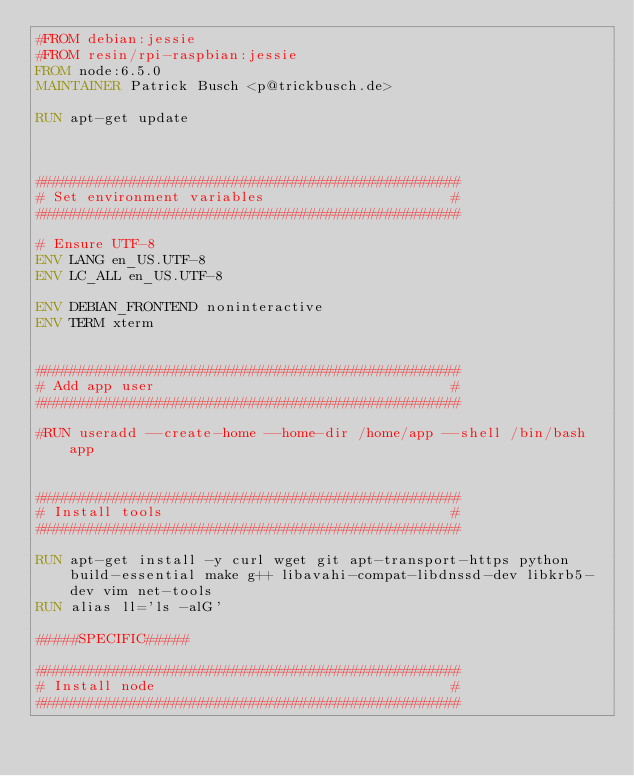<code> <loc_0><loc_0><loc_500><loc_500><_Dockerfile_>#FROM debian:jessie
#FROM resin/rpi-raspbian:jessie
FROM node:6.5.0
MAINTAINER Patrick Busch <p@trickbusch.de>

RUN apt-get update



##################################################
# Set environment variables                      #
##################################################

# Ensure UTF-8
ENV LANG en_US.UTF-8
ENV LC_ALL en_US.UTF-8

ENV DEBIAN_FRONTEND noninteractive
ENV TERM xterm


##################################################
# Add app user                                   #
##################################################

#RUN useradd --create-home --home-dir /home/app --shell /bin/bash app


##################################################
# Install tools                                  #
##################################################

RUN apt-get install -y curl wget git apt-transport-https python build-essential make g++ libavahi-compat-libdnssd-dev libkrb5-dev vim net-tools
RUN alias ll='ls -alG'

#####SPECIFIC#####

##################################################
# Install node                                   #
##################################################
</code> 